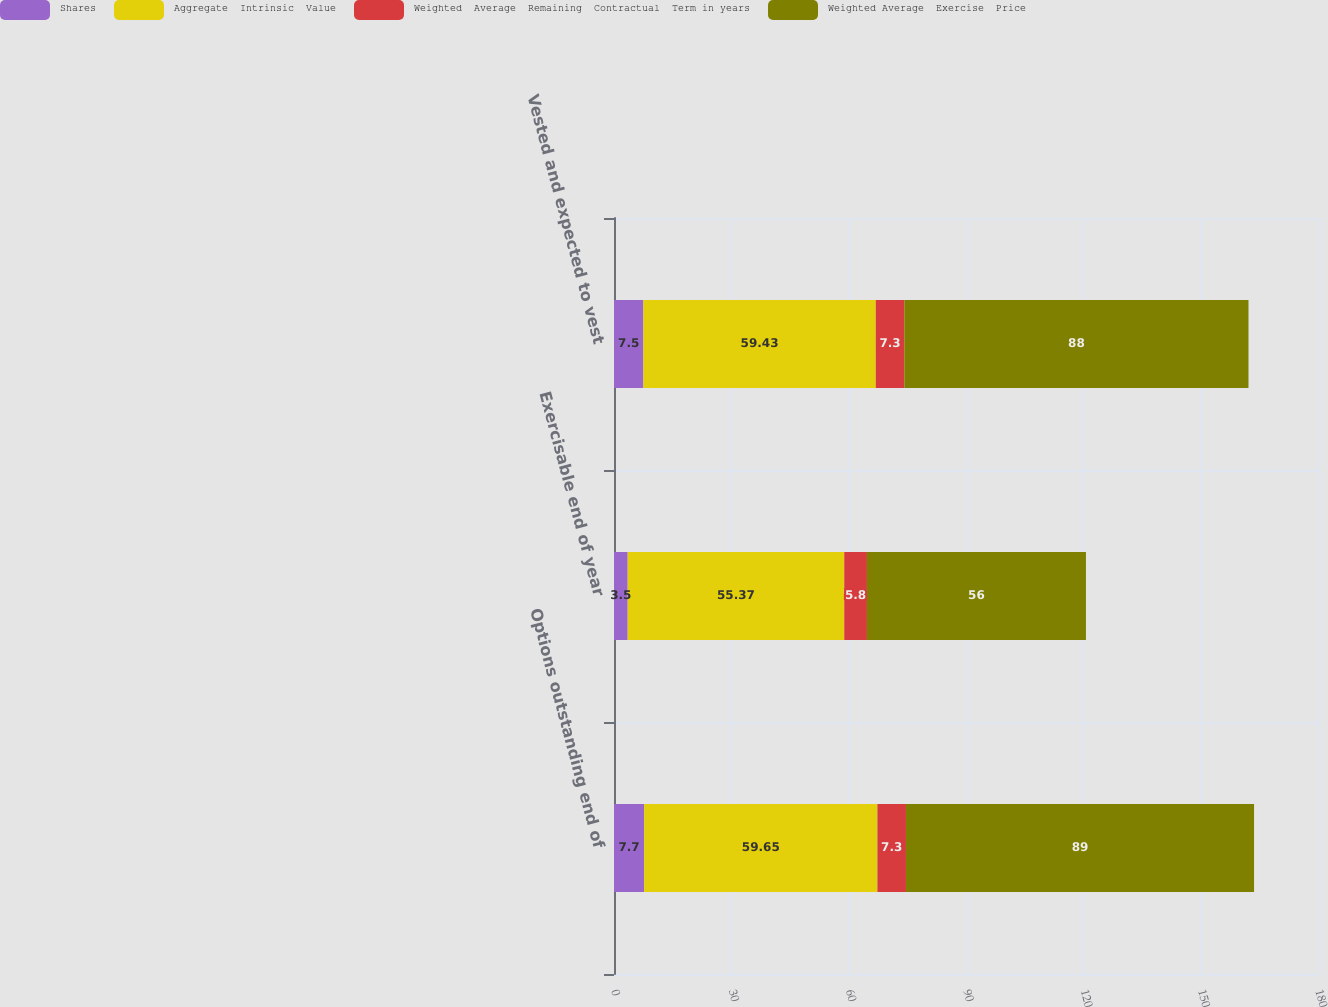Convert chart. <chart><loc_0><loc_0><loc_500><loc_500><stacked_bar_chart><ecel><fcel>Options outstanding end of<fcel>Exercisable end of year<fcel>Vested and expected to vest<nl><fcel>Shares<fcel>7.7<fcel>3.5<fcel>7.5<nl><fcel>Aggregate  Intrinsic  Value<fcel>59.65<fcel>55.37<fcel>59.43<nl><fcel>Weighted  Average  Remaining  Contractual  Term in years<fcel>7.3<fcel>5.8<fcel>7.3<nl><fcel>Weighted Average  Exercise  Price<fcel>89<fcel>56<fcel>88<nl></chart> 